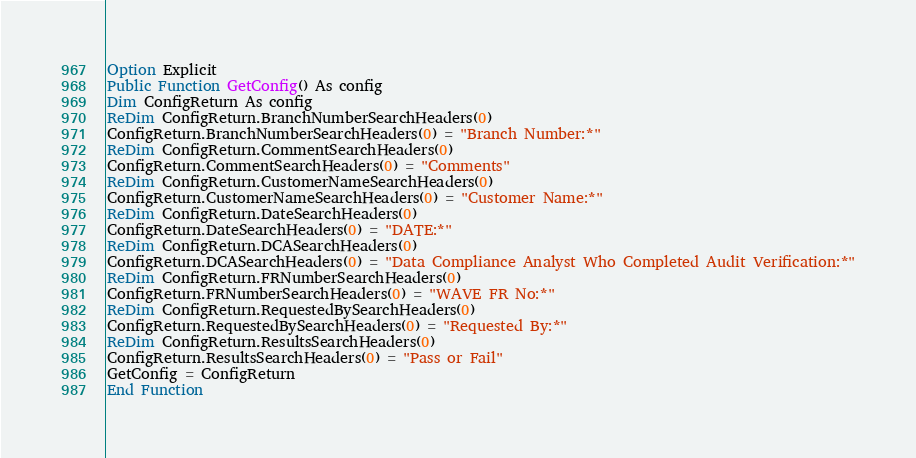<code> <loc_0><loc_0><loc_500><loc_500><_VisualBasic_>Option Explicit
Public Function GetConfig() As config
Dim ConfigReturn As config
ReDim ConfigReturn.BranchNumberSearchHeaders(0)
ConfigReturn.BranchNumberSearchHeaders(0) = "Branch Number:*"
ReDim ConfigReturn.CommentSearchHeaders(0)
ConfigReturn.CommentSearchHeaders(0) = "Comments"
ReDim ConfigReturn.CustomerNameSearchHeaders(0)
ConfigReturn.CustomerNameSearchHeaders(0) = "Customer Name:*"
ReDim ConfigReturn.DateSearchHeaders(0)
ConfigReturn.DateSearchHeaders(0) = "DATE:*"
ReDim ConfigReturn.DCASearchHeaders(0)
ConfigReturn.DCASearchHeaders(0) = "Data Compliance Analyst Who Completed Audit Verification:*"
ReDim ConfigReturn.FRNumberSearchHeaders(0)
ConfigReturn.FRNumberSearchHeaders(0) = "WAVE FR No:*"
ReDim ConfigReturn.RequestedBySearchHeaders(0)
ConfigReturn.RequestedBySearchHeaders(0) = "Requested By:*"
ReDim ConfigReturn.ResultsSearchHeaders(0)
ConfigReturn.ResultsSearchHeaders(0) = "Pass or Fail"
GetConfig = ConfigReturn
End Function
</code> 